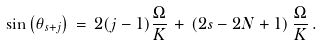Convert formula to latex. <formula><loc_0><loc_0><loc_500><loc_500>\sin { \left ( \theta _ { s + j } \right ) } \, = \, 2 ( j - 1 ) \frac { \Omega } { K } \, + \, \left ( 2 s - 2 N + 1 \right ) \frac { \Omega } { K } \, .</formula> 